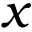<formula> <loc_0><loc_0><loc_500><loc_500>x</formula> 